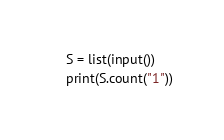<code> <loc_0><loc_0><loc_500><loc_500><_Python_>S = list(input())
print(S.count("1"))
</code> 